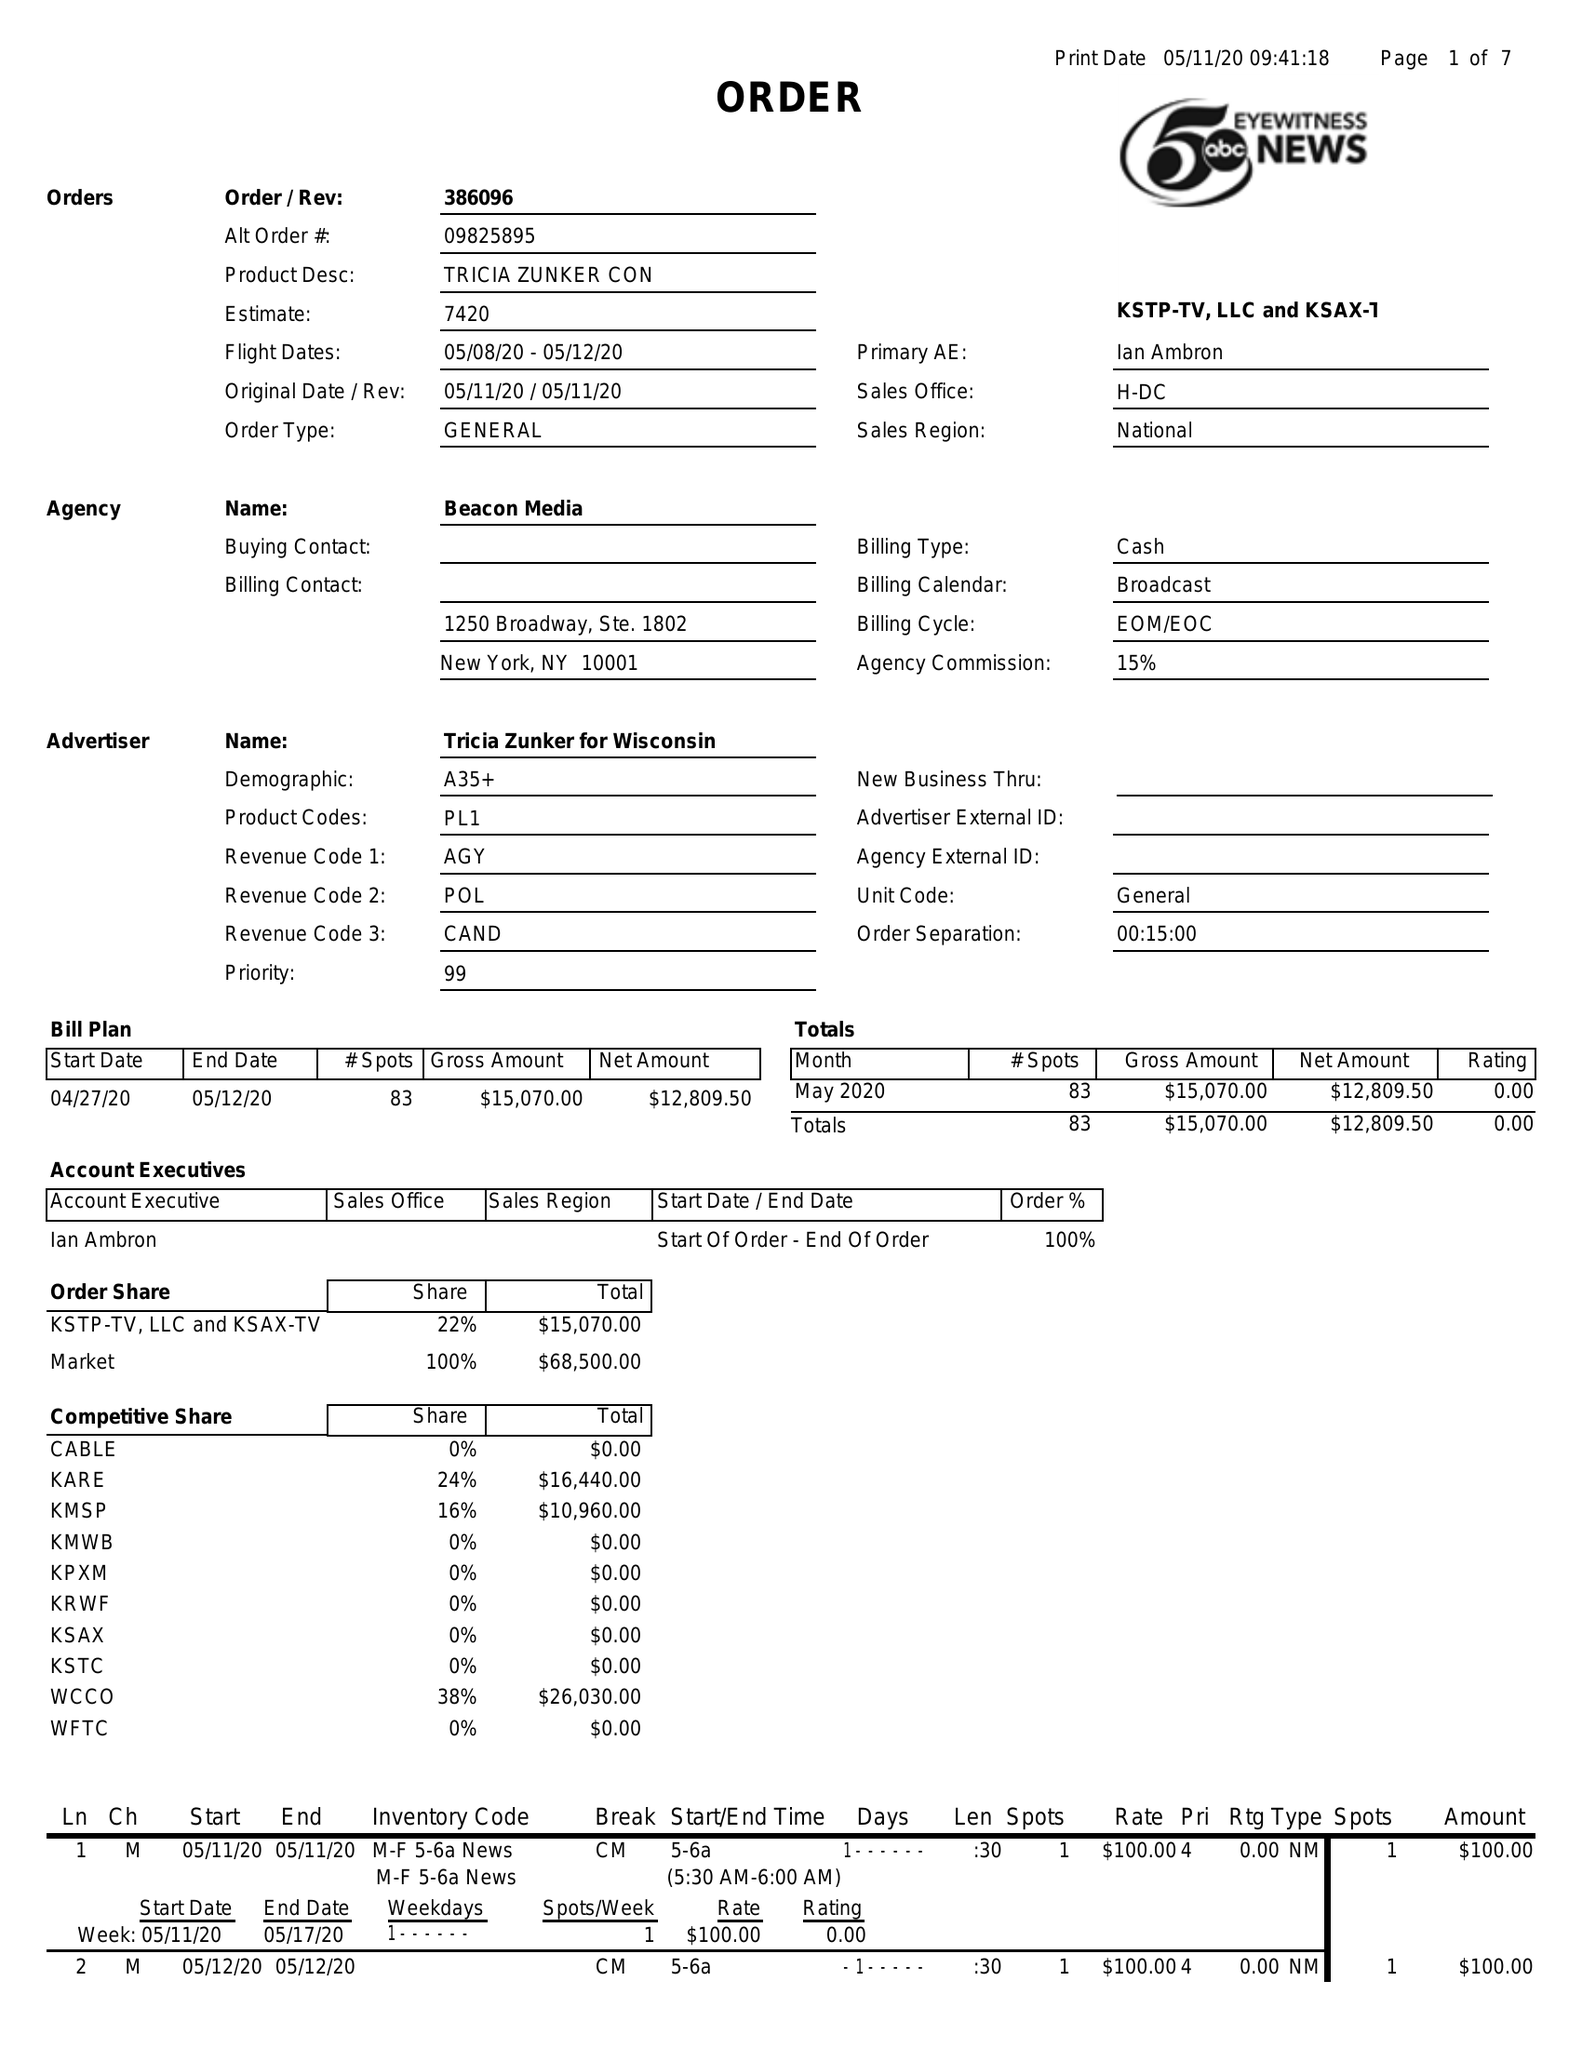What is the value for the flight_from?
Answer the question using a single word or phrase. 05/08/20 